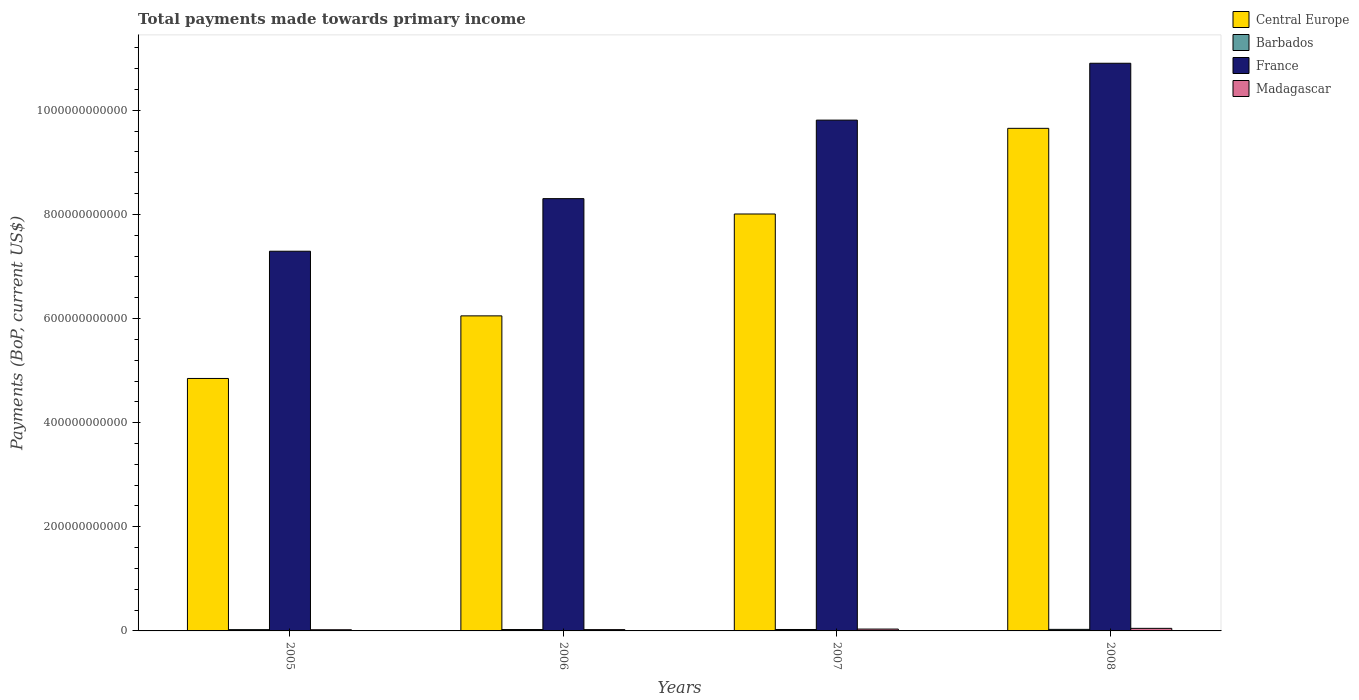How many different coloured bars are there?
Your answer should be compact. 4. How many groups of bars are there?
Your answer should be compact. 4. Are the number of bars per tick equal to the number of legend labels?
Provide a succinct answer. Yes. What is the label of the 4th group of bars from the left?
Your answer should be compact. 2008. What is the total payments made towards primary income in France in 2008?
Provide a succinct answer. 1.09e+12. Across all years, what is the maximum total payments made towards primary income in France?
Offer a very short reply. 1.09e+12. Across all years, what is the minimum total payments made towards primary income in Barbados?
Keep it short and to the point. 2.47e+09. What is the total total payments made towards primary income in Barbados in the graph?
Offer a terse response. 1.09e+1. What is the difference between the total payments made towards primary income in Barbados in 2005 and that in 2006?
Offer a very short reply. -1.96e+08. What is the difference between the total payments made towards primary income in Madagascar in 2005 and the total payments made towards primary income in Barbados in 2006?
Offer a terse response. -4.11e+08. What is the average total payments made towards primary income in Central Europe per year?
Make the answer very short. 7.14e+11. In the year 2008, what is the difference between the total payments made towards primary income in France and total payments made towards primary income in Barbados?
Make the answer very short. 1.09e+12. What is the ratio of the total payments made towards primary income in Barbados in 2006 to that in 2008?
Offer a terse response. 0.89. Is the difference between the total payments made towards primary income in France in 2005 and 2007 greater than the difference between the total payments made towards primary income in Barbados in 2005 and 2007?
Give a very brief answer. No. What is the difference between the highest and the second highest total payments made towards primary income in Barbados?
Offer a very short reply. 2.37e+08. What is the difference between the highest and the lowest total payments made towards primary income in Barbados?
Offer a very short reply. 5.27e+08. In how many years, is the total payments made towards primary income in Barbados greater than the average total payments made towards primary income in Barbados taken over all years?
Provide a short and direct response. 2. What does the 2nd bar from the left in 2005 represents?
Your answer should be very brief. Barbados. What does the 1st bar from the right in 2005 represents?
Provide a succinct answer. Madagascar. How many bars are there?
Your response must be concise. 16. How many years are there in the graph?
Offer a very short reply. 4. What is the difference between two consecutive major ticks on the Y-axis?
Give a very brief answer. 2.00e+11. Does the graph contain grids?
Your response must be concise. No. Where does the legend appear in the graph?
Offer a very short reply. Top right. How are the legend labels stacked?
Your answer should be compact. Vertical. What is the title of the graph?
Offer a very short reply. Total payments made towards primary income. What is the label or title of the Y-axis?
Keep it short and to the point. Payments (BoP, current US$). What is the Payments (BoP, current US$) in Central Europe in 2005?
Provide a short and direct response. 4.85e+11. What is the Payments (BoP, current US$) in Barbados in 2005?
Your answer should be compact. 2.47e+09. What is the Payments (BoP, current US$) of France in 2005?
Ensure brevity in your answer.  7.29e+11. What is the Payments (BoP, current US$) of Madagascar in 2005?
Your answer should be compact. 2.25e+09. What is the Payments (BoP, current US$) of Central Europe in 2006?
Offer a very short reply. 6.05e+11. What is the Payments (BoP, current US$) of Barbados in 2006?
Keep it short and to the point. 2.66e+09. What is the Payments (BoP, current US$) in France in 2006?
Ensure brevity in your answer.  8.30e+11. What is the Payments (BoP, current US$) in Madagascar in 2006?
Keep it short and to the point. 2.50e+09. What is the Payments (BoP, current US$) of Central Europe in 2007?
Make the answer very short. 8.01e+11. What is the Payments (BoP, current US$) in Barbados in 2007?
Make the answer very short. 2.76e+09. What is the Payments (BoP, current US$) of France in 2007?
Offer a very short reply. 9.81e+11. What is the Payments (BoP, current US$) of Madagascar in 2007?
Offer a terse response. 3.55e+09. What is the Payments (BoP, current US$) of Central Europe in 2008?
Keep it short and to the point. 9.65e+11. What is the Payments (BoP, current US$) of Barbados in 2008?
Your answer should be very brief. 2.99e+09. What is the Payments (BoP, current US$) of France in 2008?
Offer a terse response. 1.09e+12. What is the Payments (BoP, current US$) in Madagascar in 2008?
Offer a very short reply. 4.94e+09. Across all years, what is the maximum Payments (BoP, current US$) of Central Europe?
Your answer should be compact. 9.65e+11. Across all years, what is the maximum Payments (BoP, current US$) of Barbados?
Offer a terse response. 2.99e+09. Across all years, what is the maximum Payments (BoP, current US$) of France?
Keep it short and to the point. 1.09e+12. Across all years, what is the maximum Payments (BoP, current US$) in Madagascar?
Make the answer very short. 4.94e+09. Across all years, what is the minimum Payments (BoP, current US$) of Central Europe?
Your answer should be compact. 4.85e+11. Across all years, what is the minimum Payments (BoP, current US$) in Barbados?
Keep it short and to the point. 2.47e+09. Across all years, what is the minimum Payments (BoP, current US$) in France?
Your answer should be compact. 7.29e+11. Across all years, what is the minimum Payments (BoP, current US$) in Madagascar?
Provide a short and direct response. 2.25e+09. What is the total Payments (BoP, current US$) of Central Europe in the graph?
Offer a very short reply. 2.86e+12. What is the total Payments (BoP, current US$) in Barbados in the graph?
Your answer should be compact. 1.09e+1. What is the total Payments (BoP, current US$) of France in the graph?
Make the answer very short. 3.63e+12. What is the total Payments (BoP, current US$) in Madagascar in the graph?
Offer a terse response. 1.32e+1. What is the difference between the Payments (BoP, current US$) of Central Europe in 2005 and that in 2006?
Your answer should be compact. -1.20e+11. What is the difference between the Payments (BoP, current US$) of Barbados in 2005 and that in 2006?
Give a very brief answer. -1.96e+08. What is the difference between the Payments (BoP, current US$) of France in 2005 and that in 2006?
Ensure brevity in your answer.  -1.01e+11. What is the difference between the Payments (BoP, current US$) in Madagascar in 2005 and that in 2006?
Make the answer very short. -2.48e+08. What is the difference between the Payments (BoP, current US$) of Central Europe in 2005 and that in 2007?
Give a very brief answer. -3.16e+11. What is the difference between the Payments (BoP, current US$) of Barbados in 2005 and that in 2007?
Your answer should be very brief. -2.90e+08. What is the difference between the Payments (BoP, current US$) of France in 2005 and that in 2007?
Your response must be concise. -2.52e+11. What is the difference between the Payments (BoP, current US$) of Madagascar in 2005 and that in 2007?
Make the answer very short. -1.30e+09. What is the difference between the Payments (BoP, current US$) of Central Europe in 2005 and that in 2008?
Your answer should be very brief. -4.80e+11. What is the difference between the Payments (BoP, current US$) of Barbados in 2005 and that in 2008?
Ensure brevity in your answer.  -5.27e+08. What is the difference between the Payments (BoP, current US$) of France in 2005 and that in 2008?
Offer a terse response. -3.61e+11. What is the difference between the Payments (BoP, current US$) of Madagascar in 2005 and that in 2008?
Your answer should be compact. -2.68e+09. What is the difference between the Payments (BoP, current US$) in Central Europe in 2006 and that in 2007?
Give a very brief answer. -1.96e+11. What is the difference between the Payments (BoP, current US$) in Barbados in 2006 and that in 2007?
Keep it short and to the point. -9.44e+07. What is the difference between the Payments (BoP, current US$) in France in 2006 and that in 2007?
Your answer should be very brief. -1.51e+11. What is the difference between the Payments (BoP, current US$) of Madagascar in 2006 and that in 2007?
Provide a short and direct response. -1.05e+09. What is the difference between the Payments (BoP, current US$) in Central Europe in 2006 and that in 2008?
Ensure brevity in your answer.  -3.60e+11. What is the difference between the Payments (BoP, current US$) in Barbados in 2006 and that in 2008?
Make the answer very short. -3.31e+08. What is the difference between the Payments (BoP, current US$) in France in 2006 and that in 2008?
Offer a terse response. -2.60e+11. What is the difference between the Payments (BoP, current US$) of Madagascar in 2006 and that in 2008?
Make the answer very short. -2.44e+09. What is the difference between the Payments (BoP, current US$) in Central Europe in 2007 and that in 2008?
Provide a succinct answer. -1.65e+11. What is the difference between the Payments (BoP, current US$) in Barbados in 2007 and that in 2008?
Provide a short and direct response. -2.37e+08. What is the difference between the Payments (BoP, current US$) of France in 2007 and that in 2008?
Keep it short and to the point. -1.09e+11. What is the difference between the Payments (BoP, current US$) of Madagascar in 2007 and that in 2008?
Make the answer very short. -1.39e+09. What is the difference between the Payments (BoP, current US$) of Central Europe in 2005 and the Payments (BoP, current US$) of Barbados in 2006?
Your answer should be compact. 4.82e+11. What is the difference between the Payments (BoP, current US$) in Central Europe in 2005 and the Payments (BoP, current US$) in France in 2006?
Provide a short and direct response. -3.45e+11. What is the difference between the Payments (BoP, current US$) in Central Europe in 2005 and the Payments (BoP, current US$) in Madagascar in 2006?
Provide a short and direct response. 4.82e+11. What is the difference between the Payments (BoP, current US$) in Barbados in 2005 and the Payments (BoP, current US$) in France in 2006?
Ensure brevity in your answer.  -8.28e+11. What is the difference between the Payments (BoP, current US$) of Barbados in 2005 and the Payments (BoP, current US$) of Madagascar in 2006?
Keep it short and to the point. -3.30e+07. What is the difference between the Payments (BoP, current US$) of France in 2005 and the Payments (BoP, current US$) of Madagascar in 2006?
Give a very brief answer. 7.27e+11. What is the difference between the Payments (BoP, current US$) of Central Europe in 2005 and the Payments (BoP, current US$) of Barbados in 2007?
Provide a short and direct response. 4.82e+11. What is the difference between the Payments (BoP, current US$) in Central Europe in 2005 and the Payments (BoP, current US$) in France in 2007?
Your response must be concise. -4.96e+11. What is the difference between the Payments (BoP, current US$) in Central Europe in 2005 and the Payments (BoP, current US$) in Madagascar in 2007?
Offer a very short reply. 4.81e+11. What is the difference between the Payments (BoP, current US$) of Barbados in 2005 and the Payments (BoP, current US$) of France in 2007?
Give a very brief answer. -9.79e+11. What is the difference between the Payments (BoP, current US$) in Barbados in 2005 and the Payments (BoP, current US$) in Madagascar in 2007?
Offer a very short reply. -1.08e+09. What is the difference between the Payments (BoP, current US$) of France in 2005 and the Payments (BoP, current US$) of Madagascar in 2007?
Provide a succinct answer. 7.26e+11. What is the difference between the Payments (BoP, current US$) of Central Europe in 2005 and the Payments (BoP, current US$) of Barbados in 2008?
Give a very brief answer. 4.82e+11. What is the difference between the Payments (BoP, current US$) in Central Europe in 2005 and the Payments (BoP, current US$) in France in 2008?
Keep it short and to the point. -6.05e+11. What is the difference between the Payments (BoP, current US$) of Central Europe in 2005 and the Payments (BoP, current US$) of Madagascar in 2008?
Offer a terse response. 4.80e+11. What is the difference between the Payments (BoP, current US$) in Barbados in 2005 and the Payments (BoP, current US$) in France in 2008?
Provide a succinct answer. -1.09e+12. What is the difference between the Payments (BoP, current US$) of Barbados in 2005 and the Payments (BoP, current US$) of Madagascar in 2008?
Keep it short and to the point. -2.47e+09. What is the difference between the Payments (BoP, current US$) of France in 2005 and the Payments (BoP, current US$) of Madagascar in 2008?
Provide a short and direct response. 7.24e+11. What is the difference between the Payments (BoP, current US$) in Central Europe in 2006 and the Payments (BoP, current US$) in Barbados in 2007?
Your answer should be very brief. 6.02e+11. What is the difference between the Payments (BoP, current US$) in Central Europe in 2006 and the Payments (BoP, current US$) in France in 2007?
Your response must be concise. -3.76e+11. What is the difference between the Payments (BoP, current US$) of Central Europe in 2006 and the Payments (BoP, current US$) of Madagascar in 2007?
Offer a terse response. 6.02e+11. What is the difference between the Payments (BoP, current US$) in Barbados in 2006 and the Payments (BoP, current US$) in France in 2007?
Keep it short and to the point. -9.79e+11. What is the difference between the Payments (BoP, current US$) in Barbados in 2006 and the Payments (BoP, current US$) in Madagascar in 2007?
Offer a very short reply. -8.88e+08. What is the difference between the Payments (BoP, current US$) in France in 2006 and the Payments (BoP, current US$) in Madagascar in 2007?
Your answer should be very brief. 8.27e+11. What is the difference between the Payments (BoP, current US$) of Central Europe in 2006 and the Payments (BoP, current US$) of Barbados in 2008?
Your answer should be very brief. 6.02e+11. What is the difference between the Payments (BoP, current US$) in Central Europe in 2006 and the Payments (BoP, current US$) in France in 2008?
Offer a very short reply. -4.85e+11. What is the difference between the Payments (BoP, current US$) of Central Europe in 2006 and the Payments (BoP, current US$) of Madagascar in 2008?
Offer a terse response. 6.00e+11. What is the difference between the Payments (BoP, current US$) of Barbados in 2006 and the Payments (BoP, current US$) of France in 2008?
Give a very brief answer. -1.09e+12. What is the difference between the Payments (BoP, current US$) in Barbados in 2006 and the Payments (BoP, current US$) in Madagascar in 2008?
Your response must be concise. -2.27e+09. What is the difference between the Payments (BoP, current US$) of France in 2006 and the Payments (BoP, current US$) of Madagascar in 2008?
Provide a short and direct response. 8.25e+11. What is the difference between the Payments (BoP, current US$) in Central Europe in 2007 and the Payments (BoP, current US$) in Barbados in 2008?
Your response must be concise. 7.98e+11. What is the difference between the Payments (BoP, current US$) of Central Europe in 2007 and the Payments (BoP, current US$) of France in 2008?
Give a very brief answer. -2.90e+11. What is the difference between the Payments (BoP, current US$) in Central Europe in 2007 and the Payments (BoP, current US$) in Madagascar in 2008?
Offer a terse response. 7.96e+11. What is the difference between the Payments (BoP, current US$) in Barbados in 2007 and the Payments (BoP, current US$) in France in 2008?
Your answer should be compact. -1.09e+12. What is the difference between the Payments (BoP, current US$) of Barbados in 2007 and the Payments (BoP, current US$) of Madagascar in 2008?
Offer a very short reply. -2.18e+09. What is the difference between the Payments (BoP, current US$) of France in 2007 and the Payments (BoP, current US$) of Madagascar in 2008?
Ensure brevity in your answer.  9.76e+11. What is the average Payments (BoP, current US$) of Central Europe per year?
Offer a terse response. 7.14e+11. What is the average Payments (BoP, current US$) of Barbados per year?
Ensure brevity in your answer.  2.72e+09. What is the average Payments (BoP, current US$) of France per year?
Keep it short and to the point. 9.08e+11. What is the average Payments (BoP, current US$) of Madagascar per year?
Give a very brief answer. 3.31e+09. In the year 2005, what is the difference between the Payments (BoP, current US$) of Central Europe and Payments (BoP, current US$) of Barbados?
Ensure brevity in your answer.  4.82e+11. In the year 2005, what is the difference between the Payments (BoP, current US$) in Central Europe and Payments (BoP, current US$) in France?
Keep it short and to the point. -2.44e+11. In the year 2005, what is the difference between the Payments (BoP, current US$) in Central Europe and Payments (BoP, current US$) in Madagascar?
Keep it short and to the point. 4.83e+11. In the year 2005, what is the difference between the Payments (BoP, current US$) in Barbados and Payments (BoP, current US$) in France?
Provide a short and direct response. -7.27e+11. In the year 2005, what is the difference between the Payments (BoP, current US$) in Barbados and Payments (BoP, current US$) in Madagascar?
Ensure brevity in your answer.  2.15e+08. In the year 2005, what is the difference between the Payments (BoP, current US$) of France and Payments (BoP, current US$) of Madagascar?
Make the answer very short. 7.27e+11. In the year 2006, what is the difference between the Payments (BoP, current US$) of Central Europe and Payments (BoP, current US$) of Barbados?
Your response must be concise. 6.03e+11. In the year 2006, what is the difference between the Payments (BoP, current US$) of Central Europe and Payments (BoP, current US$) of France?
Ensure brevity in your answer.  -2.25e+11. In the year 2006, what is the difference between the Payments (BoP, current US$) of Central Europe and Payments (BoP, current US$) of Madagascar?
Your answer should be very brief. 6.03e+11. In the year 2006, what is the difference between the Payments (BoP, current US$) in Barbados and Payments (BoP, current US$) in France?
Keep it short and to the point. -8.28e+11. In the year 2006, what is the difference between the Payments (BoP, current US$) in Barbados and Payments (BoP, current US$) in Madagascar?
Offer a terse response. 1.63e+08. In the year 2006, what is the difference between the Payments (BoP, current US$) in France and Payments (BoP, current US$) in Madagascar?
Make the answer very short. 8.28e+11. In the year 2007, what is the difference between the Payments (BoP, current US$) in Central Europe and Payments (BoP, current US$) in Barbados?
Give a very brief answer. 7.98e+11. In the year 2007, what is the difference between the Payments (BoP, current US$) in Central Europe and Payments (BoP, current US$) in France?
Your response must be concise. -1.80e+11. In the year 2007, what is the difference between the Payments (BoP, current US$) in Central Europe and Payments (BoP, current US$) in Madagascar?
Ensure brevity in your answer.  7.97e+11. In the year 2007, what is the difference between the Payments (BoP, current US$) in Barbados and Payments (BoP, current US$) in France?
Make the answer very short. -9.78e+11. In the year 2007, what is the difference between the Payments (BoP, current US$) in Barbados and Payments (BoP, current US$) in Madagascar?
Provide a succinct answer. -7.94e+08. In the year 2007, what is the difference between the Payments (BoP, current US$) of France and Payments (BoP, current US$) of Madagascar?
Offer a terse response. 9.78e+11. In the year 2008, what is the difference between the Payments (BoP, current US$) of Central Europe and Payments (BoP, current US$) of Barbados?
Keep it short and to the point. 9.62e+11. In the year 2008, what is the difference between the Payments (BoP, current US$) in Central Europe and Payments (BoP, current US$) in France?
Offer a very short reply. -1.25e+11. In the year 2008, what is the difference between the Payments (BoP, current US$) in Central Europe and Payments (BoP, current US$) in Madagascar?
Provide a succinct answer. 9.60e+11. In the year 2008, what is the difference between the Payments (BoP, current US$) in Barbados and Payments (BoP, current US$) in France?
Make the answer very short. -1.09e+12. In the year 2008, what is the difference between the Payments (BoP, current US$) of Barbados and Payments (BoP, current US$) of Madagascar?
Keep it short and to the point. -1.94e+09. In the year 2008, what is the difference between the Payments (BoP, current US$) in France and Payments (BoP, current US$) in Madagascar?
Offer a very short reply. 1.09e+12. What is the ratio of the Payments (BoP, current US$) in Central Europe in 2005 to that in 2006?
Make the answer very short. 0.8. What is the ratio of the Payments (BoP, current US$) of Barbados in 2005 to that in 2006?
Make the answer very short. 0.93. What is the ratio of the Payments (BoP, current US$) of France in 2005 to that in 2006?
Ensure brevity in your answer.  0.88. What is the ratio of the Payments (BoP, current US$) in Madagascar in 2005 to that in 2006?
Your answer should be compact. 0.9. What is the ratio of the Payments (BoP, current US$) of Central Europe in 2005 to that in 2007?
Give a very brief answer. 0.61. What is the ratio of the Payments (BoP, current US$) of Barbados in 2005 to that in 2007?
Ensure brevity in your answer.  0.89. What is the ratio of the Payments (BoP, current US$) of France in 2005 to that in 2007?
Offer a very short reply. 0.74. What is the ratio of the Payments (BoP, current US$) in Madagascar in 2005 to that in 2007?
Ensure brevity in your answer.  0.63. What is the ratio of the Payments (BoP, current US$) in Central Europe in 2005 to that in 2008?
Make the answer very short. 0.5. What is the ratio of the Payments (BoP, current US$) in Barbados in 2005 to that in 2008?
Your response must be concise. 0.82. What is the ratio of the Payments (BoP, current US$) in France in 2005 to that in 2008?
Make the answer very short. 0.67. What is the ratio of the Payments (BoP, current US$) in Madagascar in 2005 to that in 2008?
Give a very brief answer. 0.46. What is the ratio of the Payments (BoP, current US$) of Central Europe in 2006 to that in 2007?
Offer a very short reply. 0.76. What is the ratio of the Payments (BoP, current US$) in Barbados in 2006 to that in 2007?
Ensure brevity in your answer.  0.97. What is the ratio of the Payments (BoP, current US$) in France in 2006 to that in 2007?
Provide a short and direct response. 0.85. What is the ratio of the Payments (BoP, current US$) of Madagascar in 2006 to that in 2007?
Offer a very short reply. 0.7. What is the ratio of the Payments (BoP, current US$) of Central Europe in 2006 to that in 2008?
Ensure brevity in your answer.  0.63. What is the ratio of the Payments (BoP, current US$) in Barbados in 2006 to that in 2008?
Provide a succinct answer. 0.89. What is the ratio of the Payments (BoP, current US$) in France in 2006 to that in 2008?
Offer a terse response. 0.76. What is the ratio of the Payments (BoP, current US$) of Madagascar in 2006 to that in 2008?
Ensure brevity in your answer.  0.51. What is the ratio of the Payments (BoP, current US$) in Central Europe in 2007 to that in 2008?
Offer a terse response. 0.83. What is the ratio of the Payments (BoP, current US$) of Barbados in 2007 to that in 2008?
Provide a short and direct response. 0.92. What is the ratio of the Payments (BoP, current US$) in France in 2007 to that in 2008?
Make the answer very short. 0.9. What is the ratio of the Payments (BoP, current US$) of Madagascar in 2007 to that in 2008?
Your answer should be compact. 0.72. What is the difference between the highest and the second highest Payments (BoP, current US$) of Central Europe?
Provide a succinct answer. 1.65e+11. What is the difference between the highest and the second highest Payments (BoP, current US$) of Barbados?
Offer a very short reply. 2.37e+08. What is the difference between the highest and the second highest Payments (BoP, current US$) of France?
Your answer should be very brief. 1.09e+11. What is the difference between the highest and the second highest Payments (BoP, current US$) in Madagascar?
Offer a terse response. 1.39e+09. What is the difference between the highest and the lowest Payments (BoP, current US$) of Central Europe?
Your response must be concise. 4.80e+11. What is the difference between the highest and the lowest Payments (BoP, current US$) in Barbados?
Offer a very short reply. 5.27e+08. What is the difference between the highest and the lowest Payments (BoP, current US$) in France?
Provide a succinct answer. 3.61e+11. What is the difference between the highest and the lowest Payments (BoP, current US$) of Madagascar?
Your response must be concise. 2.68e+09. 